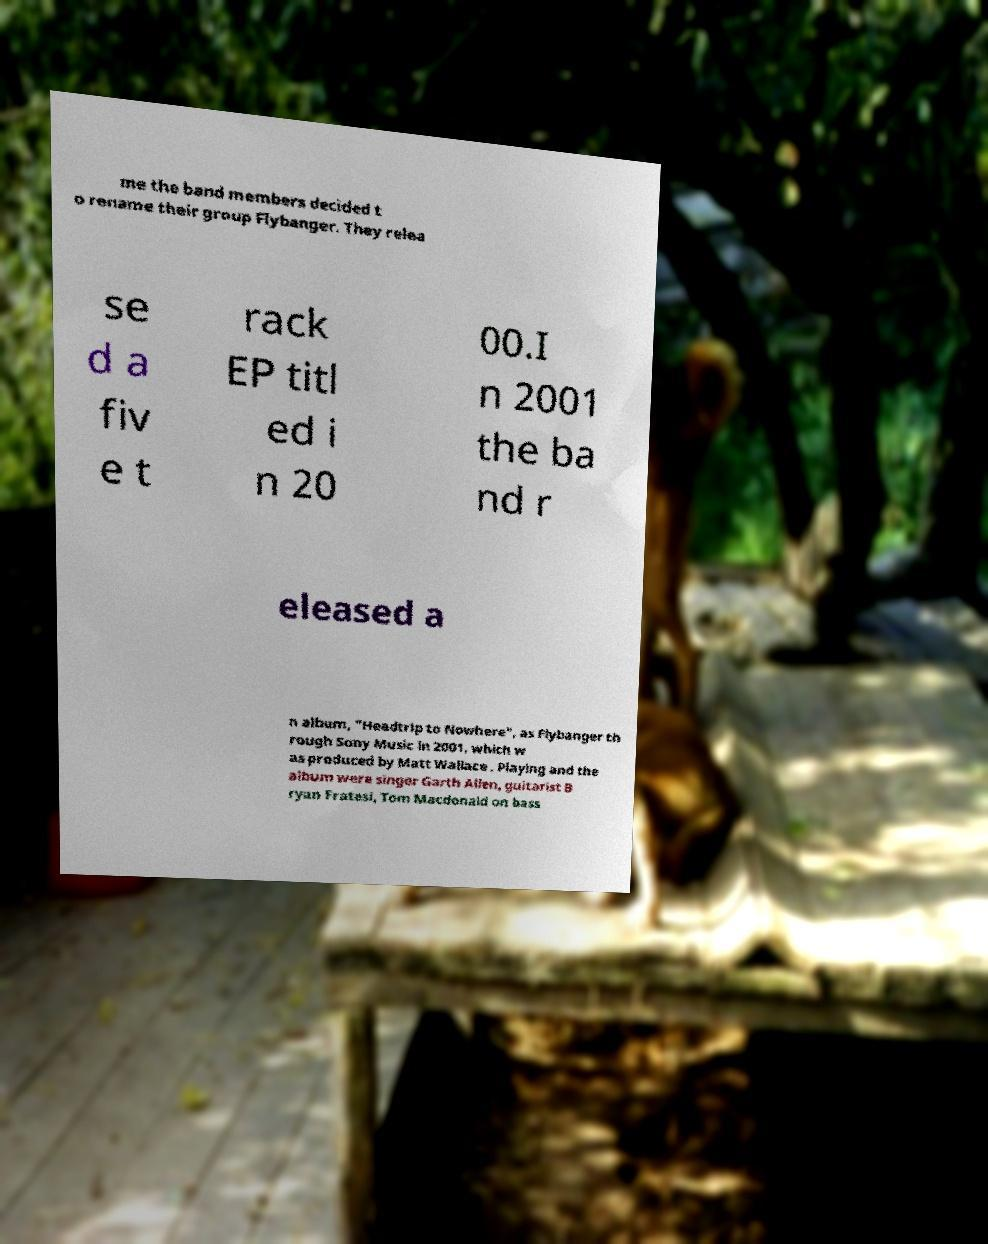I need the written content from this picture converted into text. Can you do that? me the band members decided t o rename their group Flybanger. They relea se d a fiv e t rack EP titl ed i n 20 00.I n 2001 the ba nd r eleased a n album, "Headtrip to Nowhere", as Flybanger th rough Sony Music in 2001, which w as produced by Matt Wallace . Playing and the album were singer Garth Allen, guitarist B ryan Fratesi, Tom Macdonald on bass 